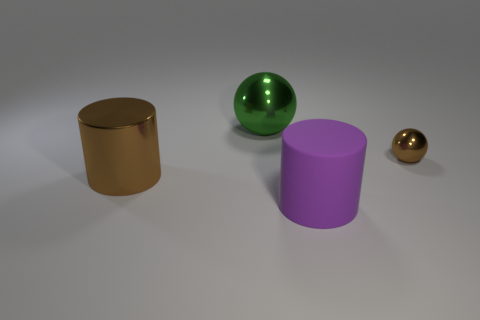Is there any other thing that is the same size as the brown sphere?
Provide a short and direct response. No. There is a large thing that is behind the brown object to the right of the large brown cylinder; what is it made of?
Provide a short and direct response. Metal. How many things are either large objects or spheres that are to the left of the large purple cylinder?
Give a very brief answer. 3. There is a brown cylinder that is made of the same material as the green thing; what size is it?
Provide a succinct answer. Large. How many brown things are either shiny cylinders or big metal cubes?
Your answer should be very brief. 1. What shape is the thing that is the same color as the big metal cylinder?
Your answer should be very brief. Sphere. Is there anything else that is the same material as the green thing?
Your answer should be compact. Yes. There is a brown thing right of the purple matte cylinder; is it the same shape as the large metal thing that is right of the big brown cylinder?
Your response must be concise. Yes. What number of small spheres are there?
Your answer should be very brief. 1. What is the shape of the tiny brown thing that is the same material as the large sphere?
Provide a succinct answer. Sphere. 